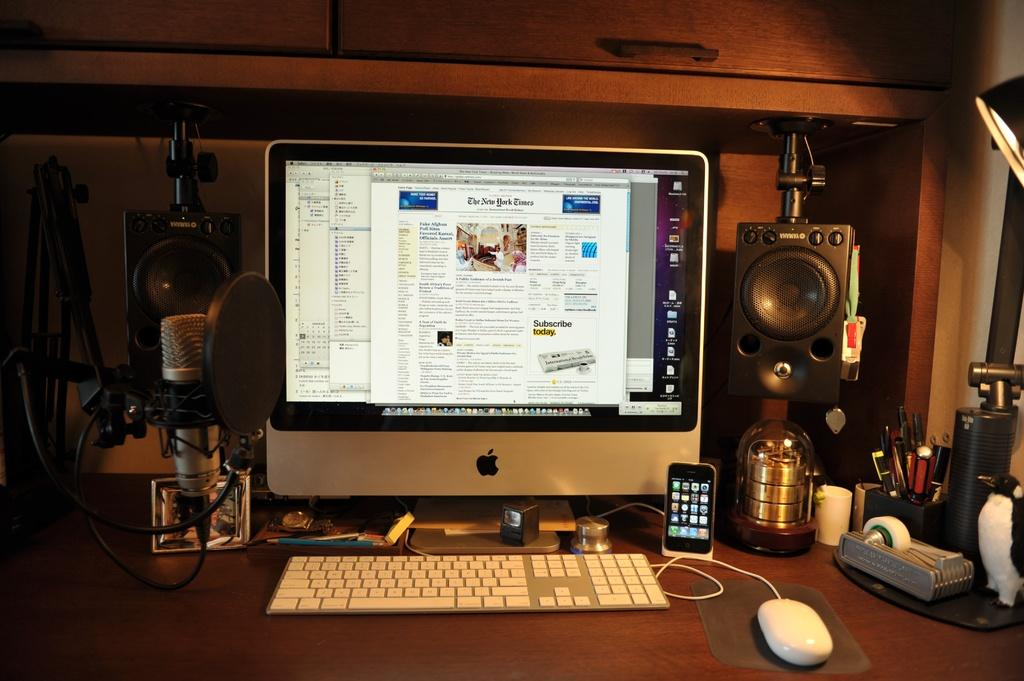What object on the table is used for amplifying sound? There is a speaker on the table, which is used for amplifying sound. What objects on the table are used for writing? There are pens on the table, which are used for writing. What object on the table is used for controlling a computer? There is a mouse on the table, which is used for controlling a computer. What object on the table is used for recording audio? There is a microphone on the table, which is used for recording audio. What object on the table is used for telling time? There is a watch on the table, which is used for telling time. What is the color of the background in the image? The background of the image is dark. Can you see a donkey sitting next to the speaker in the image? No, there is no donkey present in the image. What type of place is depicted in the image? The image does not depict a specific place; it shows objects on a table. 